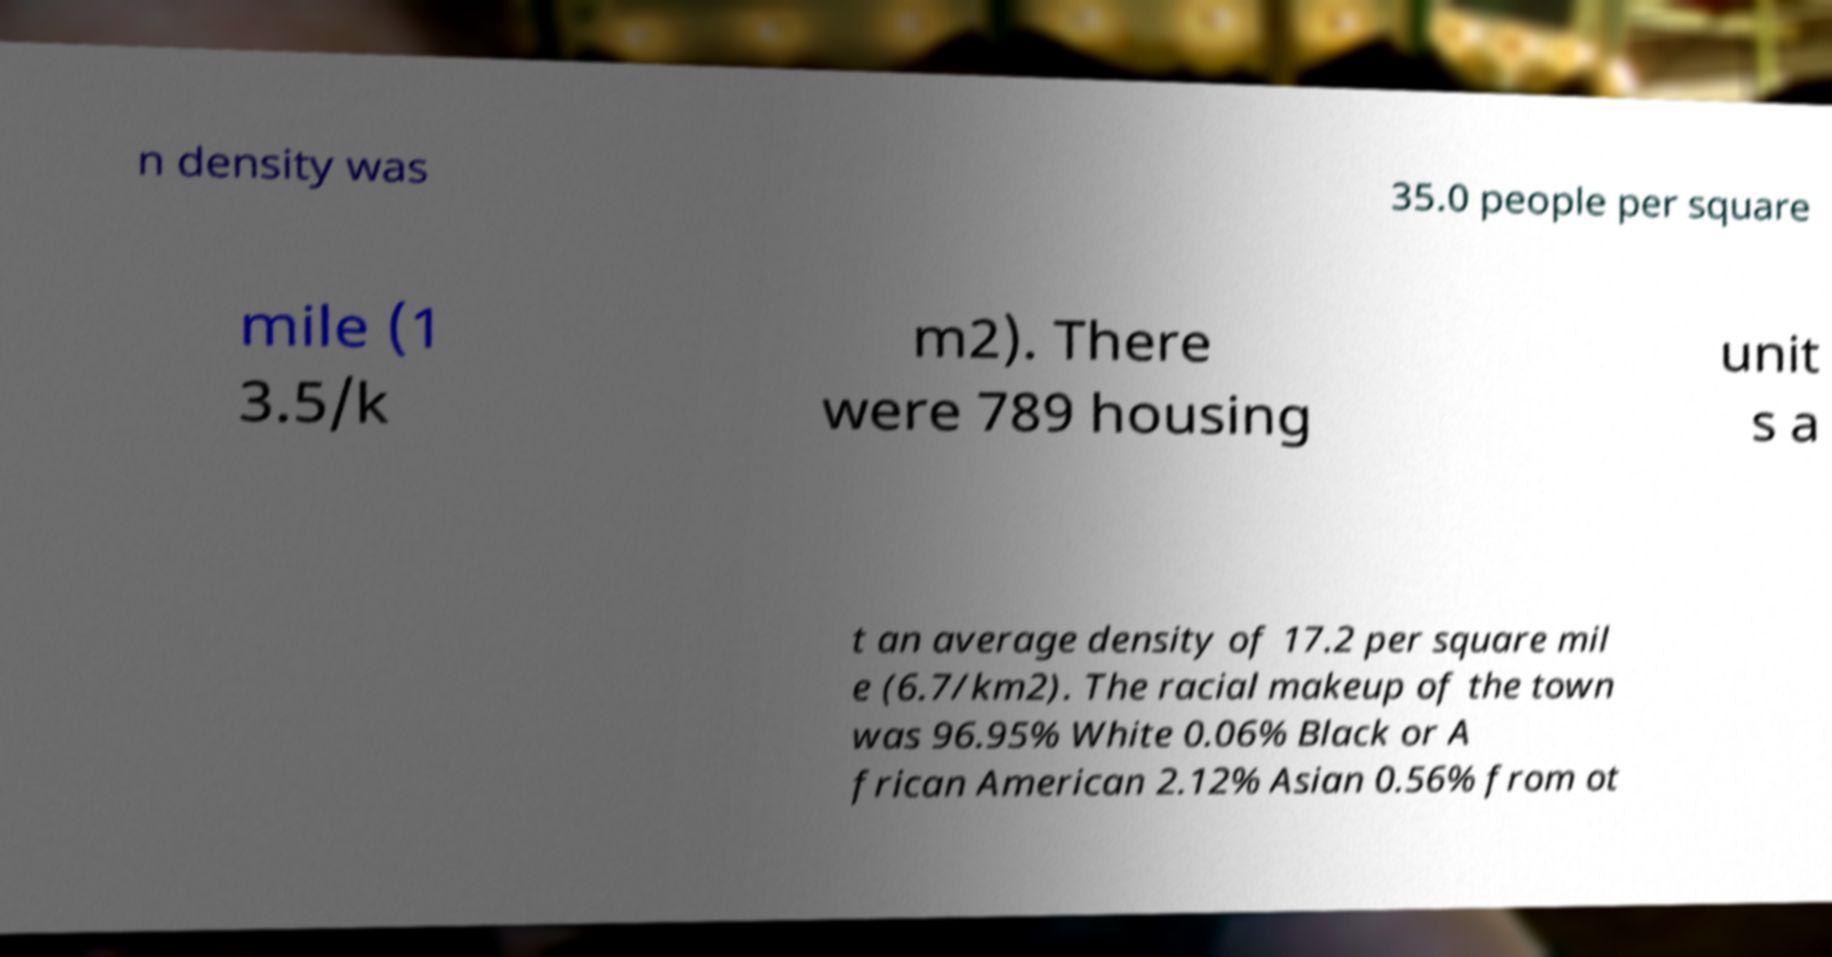Could you extract and type out the text from this image? n density was 35.0 people per square mile (1 3.5/k m2). There were 789 housing unit s a t an average density of 17.2 per square mil e (6.7/km2). The racial makeup of the town was 96.95% White 0.06% Black or A frican American 2.12% Asian 0.56% from ot 